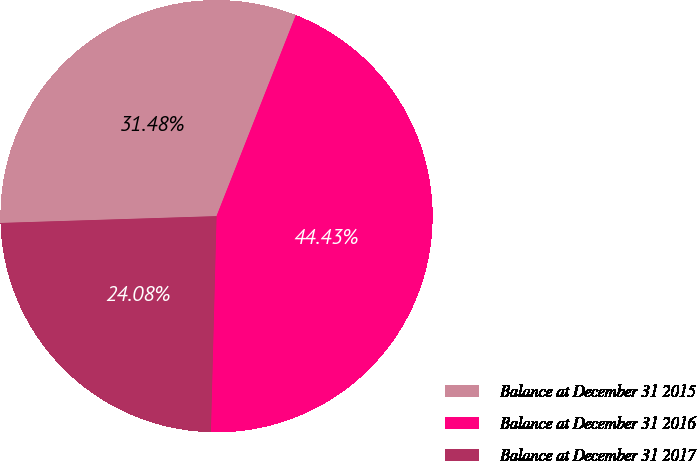<chart> <loc_0><loc_0><loc_500><loc_500><pie_chart><fcel>Balance at December 31 2015<fcel>Balance at December 31 2016<fcel>Balance at December 31 2017<nl><fcel>31.48%<fcel>44.43%<fcel>24.08%<nl></chart> 